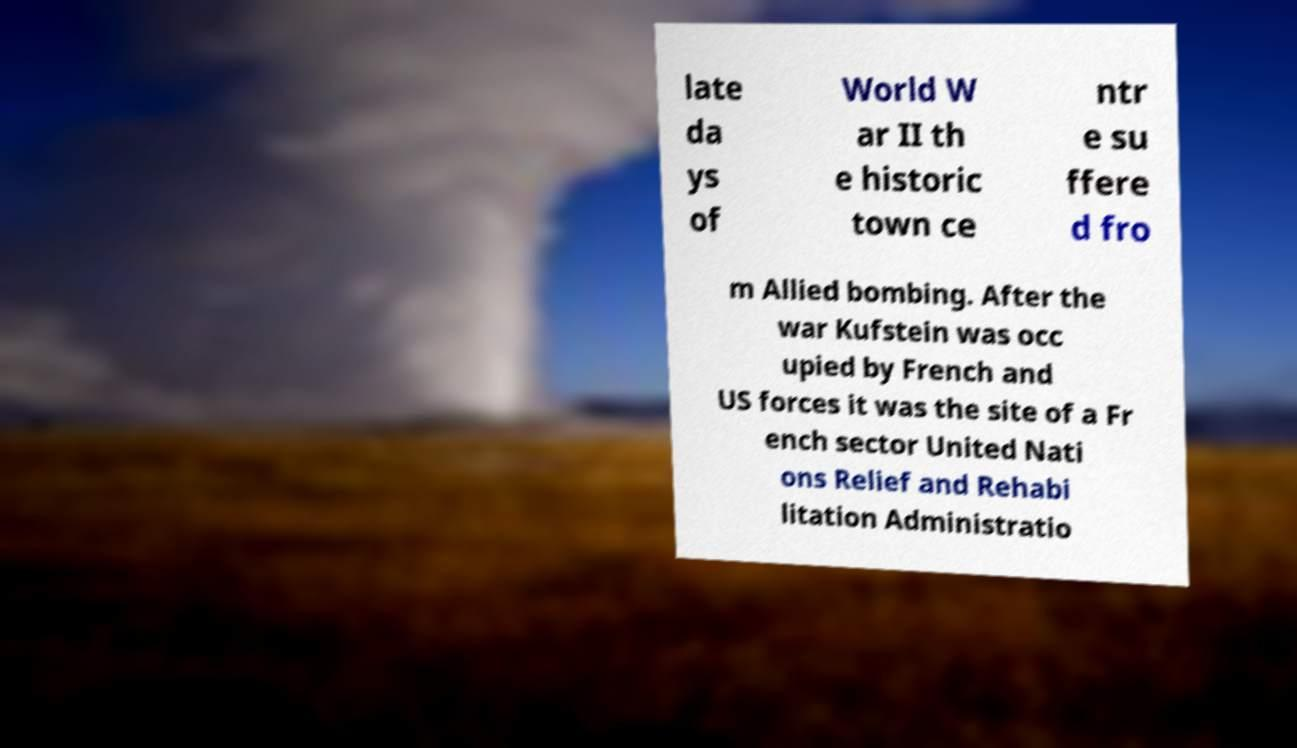I need the written content from this picture converted into text. Can you do that? late da ys of World W ar II th e historic town ce ntr e su ffere d fro m Allied bombing. After the war Kufstein was occ upied by French and US forces it was the site of a Fr ench sector United Nati ons Relief and Rehabi litation Administratio 